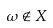Convert formula to latex. <formula><loc_0><loc_0><loc_500><loc_500>\omega \notin X</formula> 